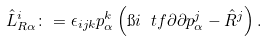Convert formula to latex. <formula><loc_0><loc_0><loc_500><loc_500>\hat { L } _ { R \alpha } ^ { i } \colon = \epsilon _ { i j k } p _ { \alpha } ^ { k } \left ( \i i \ t f { \partial } { \partial p _ { \alpha } ^ { j } } - \hat { R } ^ { j } \right ) .</formula> 